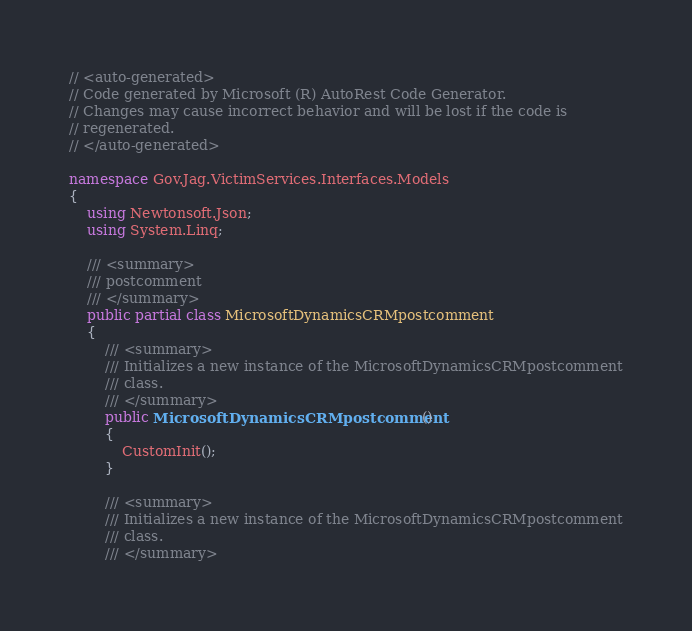<code> <loc_0><loc_0><loc_500><loc_500><_C#_>// <auto-generated>
// Code generated by Microsoft (R) AutoRest Code Generator.
// Changes may cause incorrect behavior and will be lost if the code is
// regenerated.
// </auto-generated>

namespace Gov.Jag.VictimServices.Interfaces.Models
{
    using Newtonsoft.Json;
    using System.Linq;

    /// <summary>
    /// postcomment
    /// </summary>
    public partial class MicrosoftDynamicsCRMpostcomment
    {
        /// <summary>
        /// Initializes a new instance of the MicrosoftDynamicsCRMpostcomment
        /// class.
        /// </summary>
        public MicrosoftDynamicsCRMpostcomment()
        {
            CustomInit();
        }

        /// <summary>
        /// Initializes a new instance of the MicrosoftDynamicsCRMpostcomment
        /// class.
        /// </summary></code> 